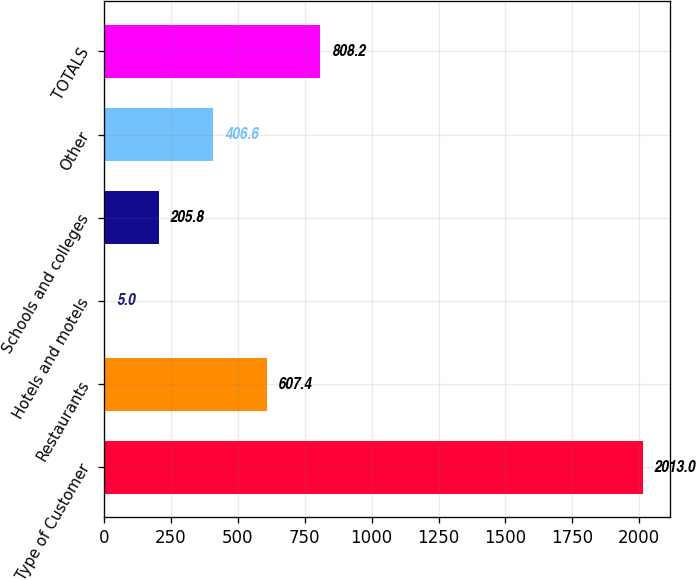Convert chart. <chart><loc_0><loc_0><loc_500><loc_500><bar_chart><fcel>Type of Customer<fcel>Restaurants<fcel>Hotels and motels<fcel>Schools and colleges<fcel>Other<fcel>TOTALS<nl><fcel>2013<fcel>607.4<fcel>5<fcel>205.8<fcel>406.6<fcel>808.2<nl></chart> 